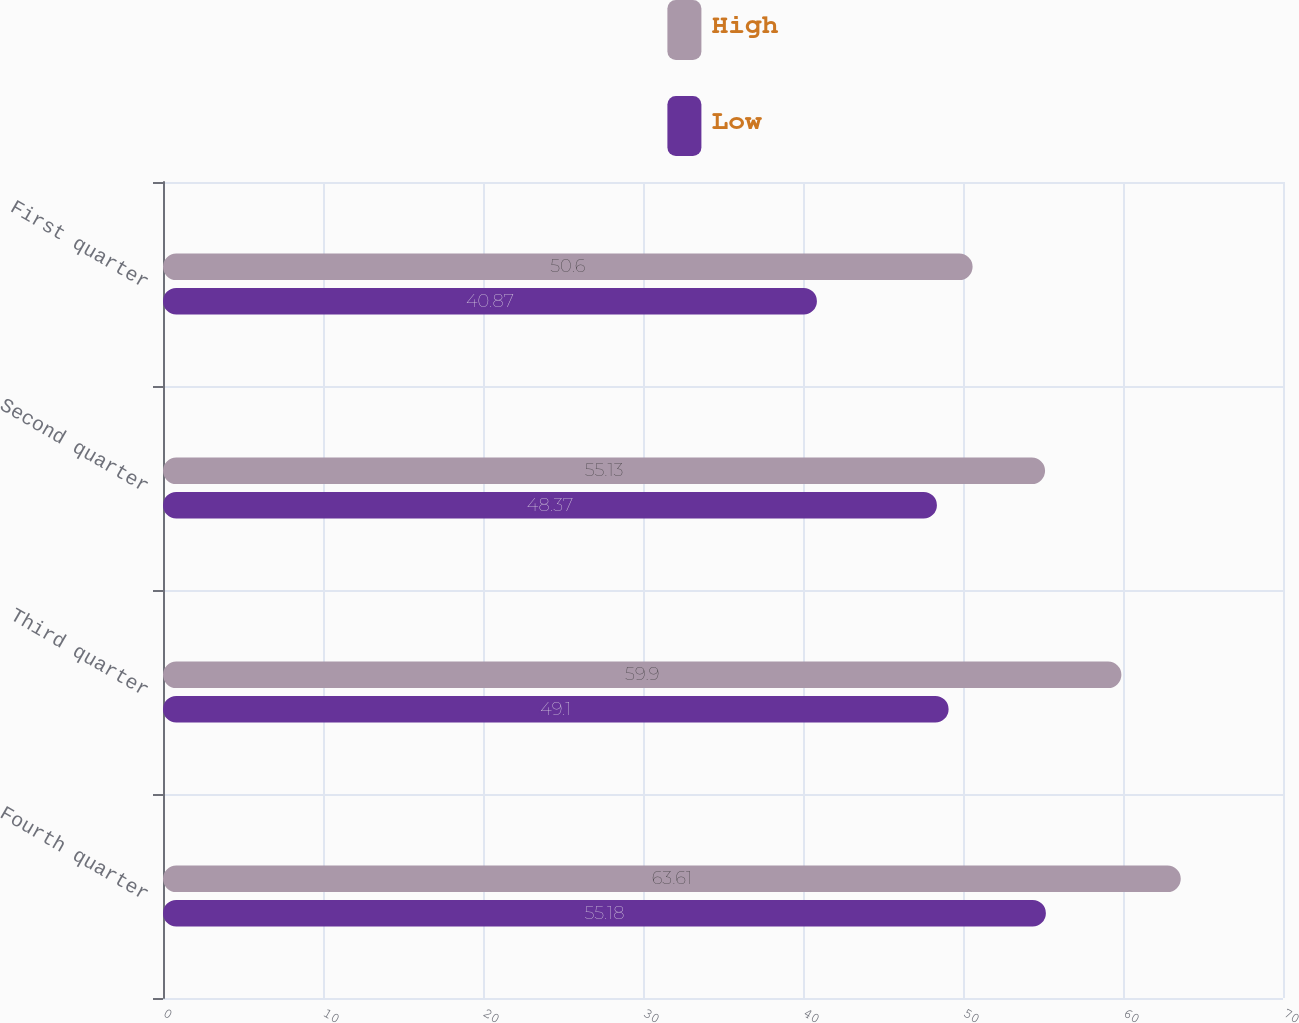<chart> <loc_0><loc_0><loc_500><loc_500><stacked_bar_chart><ecel><fcel>Fourth quarter<fcel>Third quarter<fcel>Second quarter<fcel>First quarter<nl><fcel>High<fcel>63.61<fcel>59.9<fcel>55.13<fcel>50.6<nl><fcel>Low<fcel>55.18<fcel>49.1<fcel>48.37<fcel>40.87<nl></chart> 